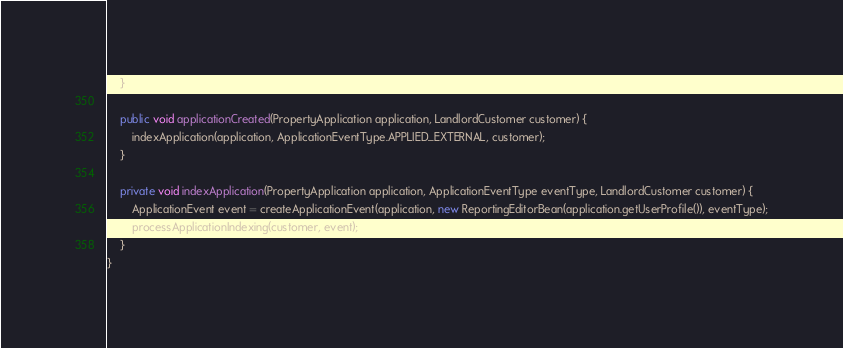Convert code to text. <code><loc_0><loc_0><loc_500><loc_500><_Java_>    }

    public void applicationCreated(PropertyApplication application, LandlordCustomer customer) {
        indexApplication(application, ApplicationEventType.APPLIED_EXTERNAL, customer);
    }

    private void indexApplication(PropertyApplication application, ApplicationEventType eventType, LandlordCustomer customer) {
        ApplicationEvent event = createApplicationEvent(application, new ReportingEditorBean(application.getUserProfile()), eventType);
        processApplicationIndexing(customer, event);
    }
}
</code> 